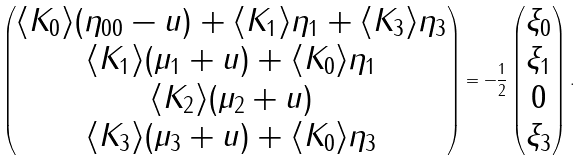<formula> <loc_0><loc_0><loc_500><loc_500>\begin{pmatrix} \langle K _ { 0 } \rangle ( \eta _ { 0 0 } - u ) + \langle K _ { 1 } \rangle \eta _ { 1 } + \langle K _ { 3 } \rangle \eta _ { 3 } \\ \langle K _ { 1 } \rangle ( \mu _ { 1 } + u ) + \langle K _ { 0 } \rangle \eta _ { 1 } \\ \langle K _ { 2 } \rangle ( \mu _ { 2 } + u ) \\ \langle K _ { 3 } \rangle ( \mu _ { 3 } + u ) + \langle K _ { 0 } \rangle \eta _ { 3 } \end{pmatrix} = - \frac { 1 } { 2 } \begin{pmatrix} \xi _ { 0 } \\ \xi _ { 1 } \\ 0 \\ \xi _ { 3 } \\ \end{pmatrix} .</formula> 